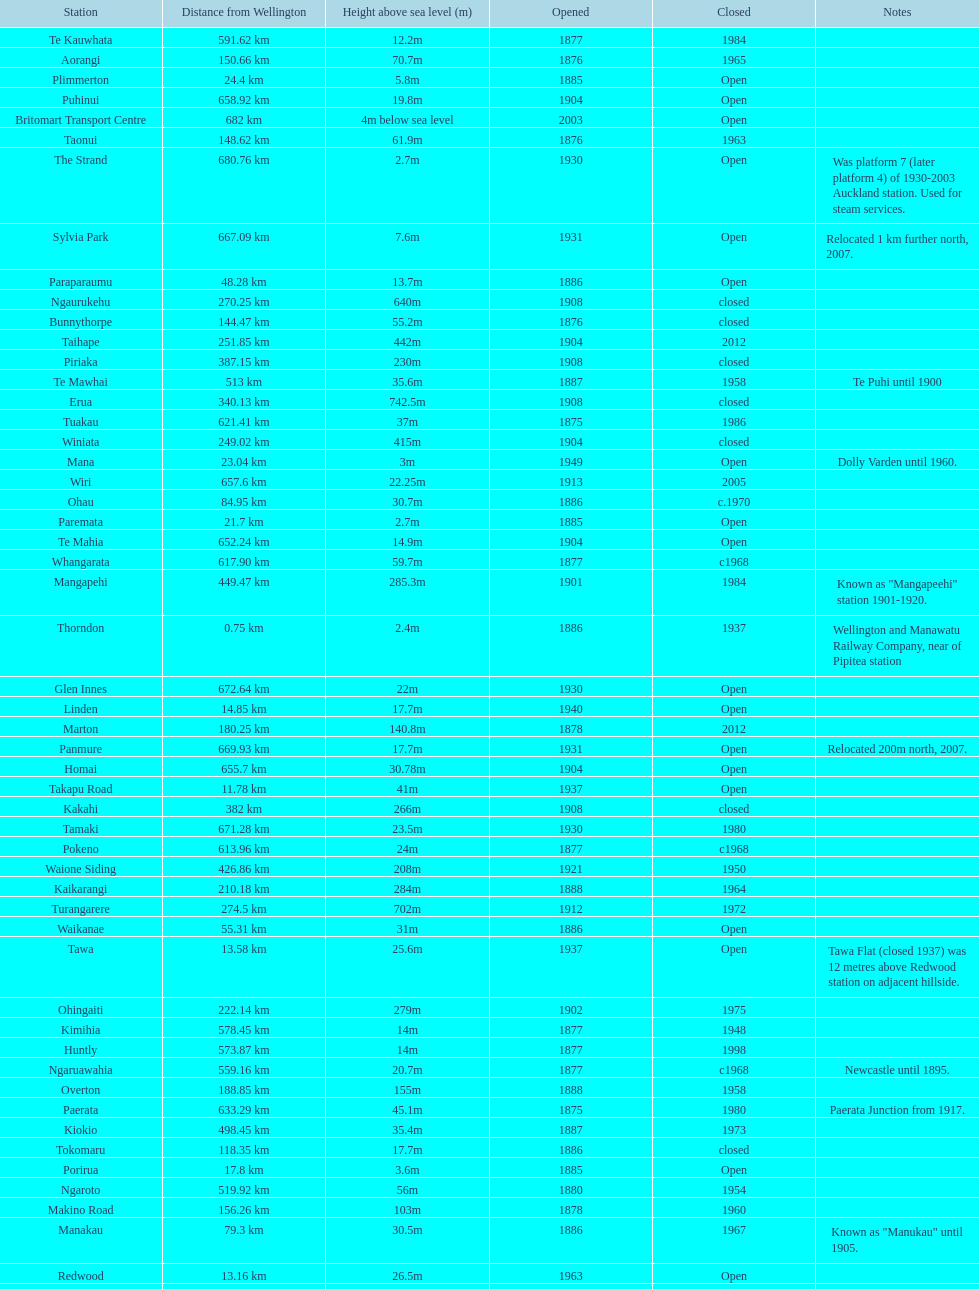How much higher is the takapu road station than the wellington station? 38.6m. 